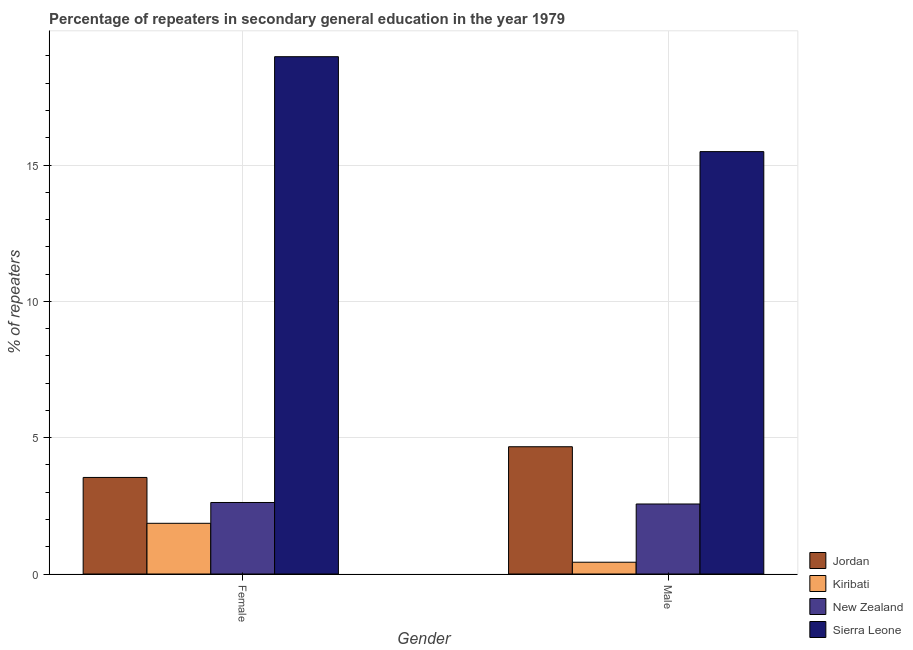How many different coloured bars are there?
Offer a very short reply. 4. How many groups of bars are there?
Provide a short and direct response. 2. How many bars are there on the 2nd tick from the left?
Provide a short and direct response. 4. What is the percentage of female repeaters in Sierra Leone?
Your response must be concise. 18.97. Across all countries, what is the maximum percentage of male repeaters?
Offer a terse response. 15.49. Across all countries, what is the minimum percentage of female repeaters?
Give a very brief answer. 1.86. In which country was the percentage of male repeaters maximum?
Provide a short and direct response. Sierra Leone. In which country was the percentage of male repeaters minimum?
Your answer should be very brief. Kiribati. What is the total percentage of female repeaters in the graph?
Ensure brevity in your answer.  27. What is the difference between the percentage of male repeaters in Sierra Leone and that in New Zealand?
Your answer should be compact. 12.92. What is the difference between the percentage of male repeaters in Jordan and the percentage of female repeaters in New Zealand?
Provide a succinct answer. 2.04. What is the average percentage of male repeaters per country?
Make the answer very short. 5.79. What is the difference between the percentage of male repeaters and percentage of female repeaters in Sierra Leone?
Offer a very short reply. -3.48. In how many countries, is the percentage of female repeaters greater than 7 %?
Your answer should be compact. 1. What is the ratio of the percentage of female repeaters in Sierra Leone to that in Kiribati?
Make the answer very short. 10.2. Is the percentage of male repeaters in Kiribati less than that in New Zealand?
Your answer should be compact. Yes. In how many countries, is the percentage of male repeaters greater than the average percentage of male repeaters taken over all countries?
Provide a succinct answer. 1. What does the 2nd bar from the left in Male represents?
Give a very brief answer. Kiribati. What does the 3rd bar from the right in Female represents?
Keep it short and to the point. Kiribati. How many countries are there in the graph?
Ensure brevity in your answer.  4. Does the graph contain any zero values?
Provide a succinct answer. No. How are the legend labels stacked?
Your answer should be very brief. Vertical. What is the title of the graph?
Your answer should be very brief. Percentage of repeaters in secondary general education in the year 1979. What is the label or title of the X-axis?
Provide a short and direct response. Gender. What is the label or title of the Y-axis?
Your answer should be very brief. % of repeaters. What is the % of repeaters of Jordan in Female?
Give a very brief answer. 3.54. What is the % of repeaters of Kiribati in Female?
Provide a short and direct response. 1.86. What is the % of repeaters in New Zealand in Female?
Provide a succinct answer. 2.62. What is the % of repeaters in Sierra Leone in Female?
Ensure brevity in your answer.  18.97. What is the % of repeaters in Jordan in Male?
Make the answer very short. 4.67. What is the % of repeaters of Kiribati in Male?
Your answer should be very brief. 0.43. What is the % of repeaters in New Zealand in Male?
Ensure brevity in your answer.  2.57. What is the % of repeaters in Sierra Leone in Male?
Provide a succinct answer. 15.49. Across all Gender, what is the maximum % of repeaters of Jordan?
Provide a succinct answer. 4.67. Across all Gender, what is the maximum % of repeaters of Kiribati?
Give a very brief answer. 1.86. Across all Gender, what is the maximum % of repeaters of New Zealand?
Provide a short and direct response. 2.62. Across all Gender, what is the maximum % of repeaters in Sierra Leone?
Provide a succinct answer. 18.97. Across all Gender, what is the minimum % of repeaters in Jordan?
Your answer should be compact. 3.54. Across all Gender, what is the minimum % of repeaters in Kiribati?
Your answer should be very brief. 0.43. Across all Gender, what is the minimum % of repeaters of New Zealand?
Your answer should be compact. 2.57. Across all Gender, what is the minimum % of repeaters of Sierra Leone?
Provide a short and direct response. 15.49. What is the total % of repeaters in Jordan in the graph?
Keep it short and to the point. 8.21. What is the total % of repeaters of Kiribati in the graph?
Your answer should be compact. 2.29. What is the total % of repeaters in New Zealand in the graph?
Your answer should be compact. 5.19. What is the total % of repeaters in Sierra Leone in the graph?
Your response must be concise. 34.46. What is the difference between the % of repeaters in Jordan in Female and that in Male?
Offer a terse response. -1.13. What is the difference between the % of repeaters in Kiribati in Female and that in Male?
Provide a succinct answer. 1.43. What is the difference between the % of repeaters in New Zealand in Female and that in Male?
Offer a very short reply. 0.05. What is the difference between the % of repeaters in Sierra Leone in Female and that in Male?
Give a very brief answer. 3.48. What is the difference between the % of repeaters of Jordan in Female and the % of repeaters of Kiribati in Male?
Your response must be concise. 3.11. What is the difference between the % of repeaters in Jordan in Female and the % of repeaters in New Zealand in Male?
Offer a terse response. 0.97. What is the difference between the % of repeaters of Jordan in Female and the % of repeaters of Sierra Leone in Male?
Your response must be concise. -11.95. What is the difference between the % of repeaters in Kiribati in Female and the % of repeaters in New Zealand in Male?
Keep it short and to the point. -0.71. What is the difference between the % of repeaters in Kiribati in Female and the % of repeaters in Sierra Leone in Male?
Provide a succinct answer. -13.63. What is the difference between the % of repeaters of New Zealand in Female and the % of repeaters of Sierra Leone in Male?
Make the answer very short. -12.87. What is the average % of repeaters of Jordan per Gender?
Provide a short and direct response. 4.1. What is the average % of repeaters in Kiribati per Gender?
Offer a very short reply. 1.15. What is the average % of repeaters of New Zealand per Gender?
Offer a very short reply. 2.6. What is the average % of repeaters of Sierra Leone per Gender?
Make the answer very short. 17.23. What is the difference between the % of repeaters of Jordan and % of repeaters of Kiribati in Female?
Provide a short and direct response. 1.68. What is the difference between the % of repeaters of Jordan and % of repeaters of New Zealand in Female?
Provide a short and direct response. 0.92. What is the difference between the % of repeaters of Jordan and % of repeaters of Sierra Leone in Female?
Keep it short and to the point. -15.43. What is the difference between the % of repeaters of Kiribati and % of repeaters of New Zealand in Female?
Give a very brief answer. -0.76. What is the difference between the % of repeaters in Kiribati and % of repeaters in Sierra Leone in Female?
Give a very brief answer. -17.11. What is the difference between the % of repeaters in New Zealand and % of repeaters in Sierra Leone in Female?
Keep it short and to the point. -16.35. What is the difference between the % of repeaters in Jordan and % of repeaters in Kiribati in Male?
Offer a terse response. 4.24. What is the difference between the % of repeaters in Jordan and % of repeaters in New Zealand in Male?
Your answer should be very brief. 2.1. What is the difference between the % of repeaters of Jordan and % of repeaters of Sierra Leone in Male?
Make the answer very short. -10.82. What is the difference between the % of repeaters in Kiribati and % of repeaters in New Zealand in Male?
Your answer should be very brief. -2.14. What is the difference between the % of repeaters of Kiribati and % of repeaters of Sierra Leone in Male?
Keep it short and to the point. -15.06. What is the difference between the % of repeaters of New Zealand and % of repeaters of Sierra Leone in Male?
Keep it short and to the point. -12.92. What is the ratio of the % of repeaters in Jordan in Female to that in Male?
Offer a very short reply. 0.76. What is the ratio of the % of repeaters of Kiribati in Female to that in Male?
Keep it short and to the point. 4.3. What is the ratio of the % of repeaters in New Zealand in Female to that in Male?
Offer a very short reply. 1.02. What is the ratio of the % of repeaters in Sierra Leone in Female to that in Male?
Give a very brief answer. 1.22. What is the difference between the highest and the second highest % of repeaters of Jordan?
Your answer should be compact. 1.13. What is the difference between the highest and the second highest % of repeaters of Kiribati?
Give a very brief answer. 1.43. What is the difference between the highest and the second highest % of repeaters in New Zealand?
Provide a short and direct response. 0.05. What is the difference between the highest and the second highest % of repeaters of Sierra Leone?
Provide a short and direct response. 3.48. What is the difference between the highest and the lowest % of repeaters in Jordan?
Your answer should be very brief. 1.13. What is the difference between the highest and the lowest % of repeaters in Kiribati?
Keep it short and to the point. 1.43. What is the difference between the highest and the lowest % of repeaters of New Zealand?
Your answer should be compact. 0.05. What is the difference between the highest and the lowest % of repeaters of Sierra Leone?
Your answer should be compact. 3.48. 